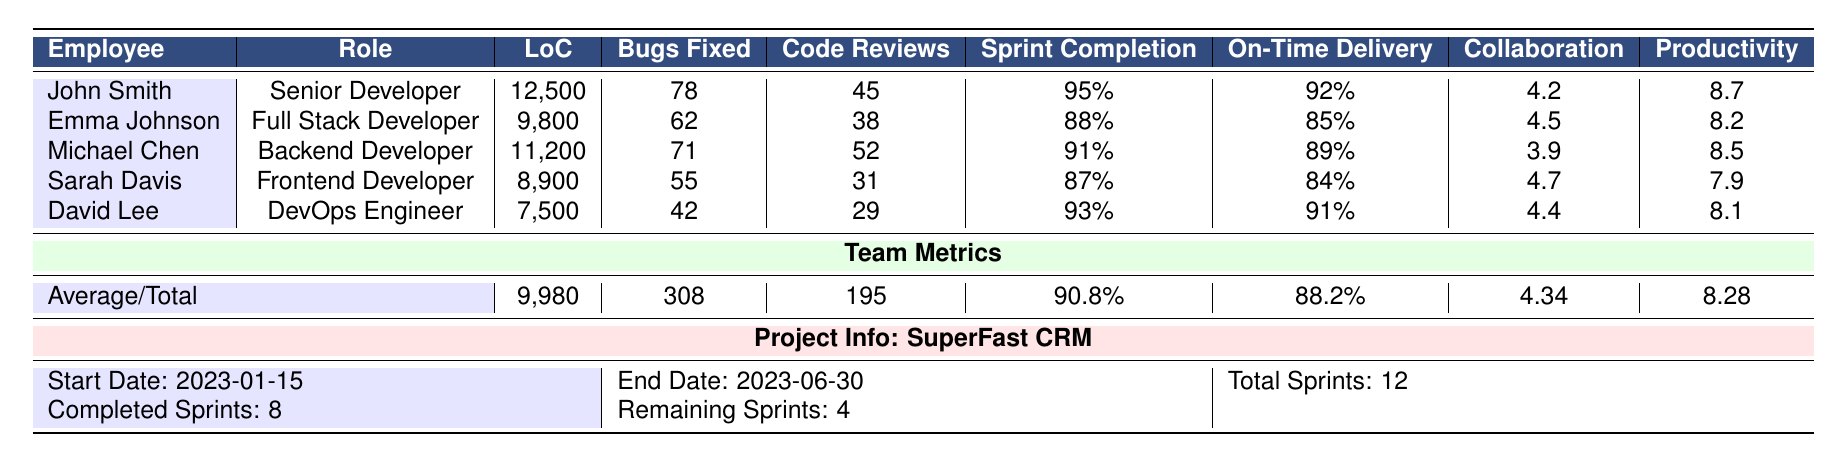What is the total number of bugs fixed by the team? The table shows that the total bugs fixed by the team is listed directly under "Total Bugs Fixed," which is stated as 308.
Answer: 308 Who has the highest productivity index? By reviewing the productivity index values for each employee, John Smith has the highest value at 8.7.
Answer: John Smith What is the average lines of code written by the team? The average lines of code for the team is mentioned under "Average/Total," listed as 9980.
Answer: 9980 What percentage of sprints has the team completed? The completed sprints are 8 out of a total of 12. To find the percentage: (8/12) * 100 = 66.67%.
Answer: 66.67% Is Emma Johnson's sprint completion rate higher than David Lee's? Emma Johnson has a sprint completion rate of 88%, while David Lee has 93%. Since 88% is lower than 93%, the answer is no.
Answer: No What is the total number of code reviews conducted by the team? The total code reviews conducted by the team is found under "Total Code Reviews," which is 195.
Answer: 195 Which employee has the lowest team collaboration score? Looking at the team collaboration scores, Michael Chen has the lowest score of 3.9.
Answer: Michael Chen What is the difference between the highest and lowest on-time delivery rates? John Smith’s on-time delivery rate is 92%, and Sarah Davis’s is 84%. The difference is 92% - 84% = 8%.
Answer: 8% Has the team completed more than two-thirds of the sprints? The team has completed 8 out of 12 sprints. Two-thirds of 12 is 8 (since 12/3 = 4, then 4 * 2 = 8). Therefore, the team has completed exactly two-thirds.
Answer: Yes Which role has the lowest average productivity index compared to the team productivity index? The team productivity index is 8.28. Comparing it with the individual productivity indices, Sarah Davis has the lowest at 7.9, which is below the team average.
Answer: Sarah Davis 